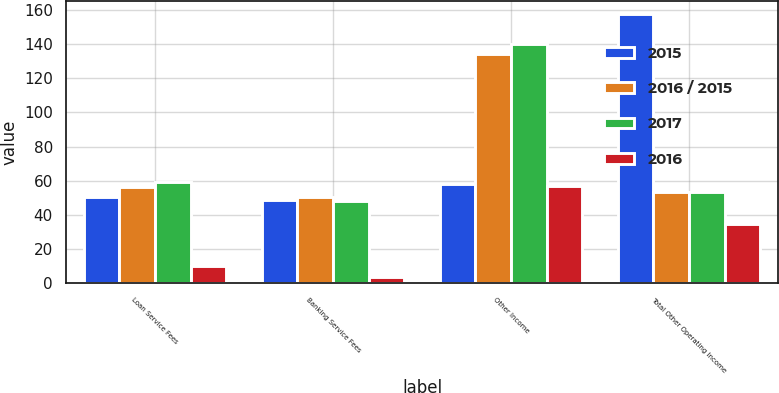<chart> <loc_0><loc_0><loc_500><loc_500><stacked_bar_chart><ecel><fcel>Loan Service Fees<fcel>Banking Service Fees<fcel>Other Income<fcel>Total Other Operating Income<nl><fcel>2015<fcel>50.7<fcel>48.6<fcel>58.2<fcel>157.5<nl><fcel>2016 / 2015<fcel>56.6<fcel>50.6<fcel>134<fcel>53.65<nl><fcel>2017<fcel>59.1<fcel>48.2<fcel>139.8<fcel>53.65<nl><fcel>2016<fcel>10<fcel>4<fcel>57<fcel>35<nl></chart> 